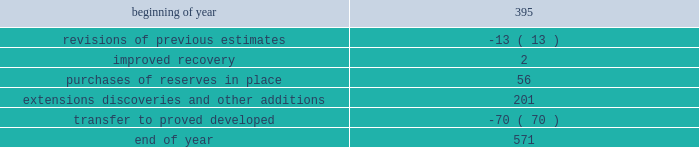Estimates of synthetic crude oil reserves are prepared by glj petroleum consultants of calgary , canada , third-party consultants .
Their reports for all years are filed as exhibits to this annual report on form 10-k .
The team lead responsible for the estimates of our osm reserves has 34 years of experience in petroleum engineering and has conducted surface mineable oil sands evaluations since 1986 .
He is a member of spe , having served as regional director from 1998 through 2001 .
The second team member has 13 years of experience in petroleum engineering and has conducted surface mineable oil sands evaluations since 2009 .
Both are registered practicing professional engineers in the province of alberta .
Audits of estimates third-party consultants are engaged to provide independent estimates for fields that comprise 80 percent of our total proved reserves over a rolling four-year period for the purpose of auditing the in-house reserve estimates .
We met this goal for the four- year period ended december 31 , 2012 .
We established a tolerance level of 10 percent such that initial estimates by the third-party consultants are accepted if they are within 10 percent of our internal estimates .
Should the third-party consultants 2019 initial analysis fail to reach our tolerance level , both our team and the consultants re-examine the information provided , request additional data and refine their analysis if appropriate .
This resolution process is continued until both estimates are within 10 percent .
In the very limited instances where differences outside the 10 percent tolerance cannot be resolved by year end , a plan to resolve the difference is developed and our senior management is informed .
This process did not result in significant changes to our reserve estimates in 2012 or 2011 .
There were no third-party audits performed in 2010 .
During 2012 , netherland , sewell & associates , inc .
( "nsai" ) prepared a certification of december 31 , 2011 reserves for the alba field in e.g .
The nsai summary report is filed as an exhibit to this annual report on form 10-k .
Members of the nsai team have many years of industry experience , having worked for large , international oil and gas companies before joining nsai .
The senior technical advisor has a bachelor of science degree in geophysics and over 15 years of experience in the estimation of and evaluation of reserves .
The second member has a bachelor of science degree in chemical engineering and master of business administration along with over 3 years of experience in estimation and evaluation of reserves .
Both are licensed in the state of texas .
Ryder scott company ( "ryder scott" ) performed audits of several of our fields in 2012 and 2011 .
Their summary reports on audits performed in 2012 and 2011 are filed as exhibits to this annual report on form 10-k .
The team lead for ryder scott has over 20 years of industry experience , having worked for a major international oil and gas company before joining ryder scott .
He has a bachelor of science degree in mechanical engineering , is a member of spe where he served on the oil and gas reserves committee and is a registered professional engineer in the state of texas .
Changes in proved undeveloped reserves as of december 31 , 2012 , 571 mmboe of proved undeveloped reserves were reported , an increase of 176 mmboe from december 31 , 2011 .
The table shows changes in total proved undeveloped reserves for 2012 : ( mmboe ) .
Significant additions to proved undeveloped reserves during 2012 include 56 mmboe due to acquisitions in the eagle ford shale .
Development drilling added 124 mmboe in the eagle ford , 35 mmboe in the bakken and 15 mmboe in the oklahoma resource basins shale play .
A gas sharing agreement signed with the libyan government in 2012 added 19 mmboe .
Additionally , 30 mmboe were transferred from proved undeveloped to proved developed reserves in the eagle ford and 14 mmboe in the bakken shale plays due to producing wells .
Costs incurred in 2012 , 2011 and 2010 relating to the development of proved undeveloped reserves , were $ 1995 million $ 1107 million and $ 1463 million .
A total of 27 mmboe was booked as a result of reliable technology .
Technologies included statistical analysis of production performance , decline curve analysis , rate transient analysis , reservoir simulation and volumetric analysis .
The statistical nature of production performance coupled with highly certain reservoir continuity or quality within the reliable technology areas and sufficient proved undeveloped locations establish the reasonable certainty criteria required for booking reserves. .
What percentage of 2012 undeveloped reserves consisted of extensions discoveries and other additions? 
Computations: (201 / 571)
Answer: 0.35201. 